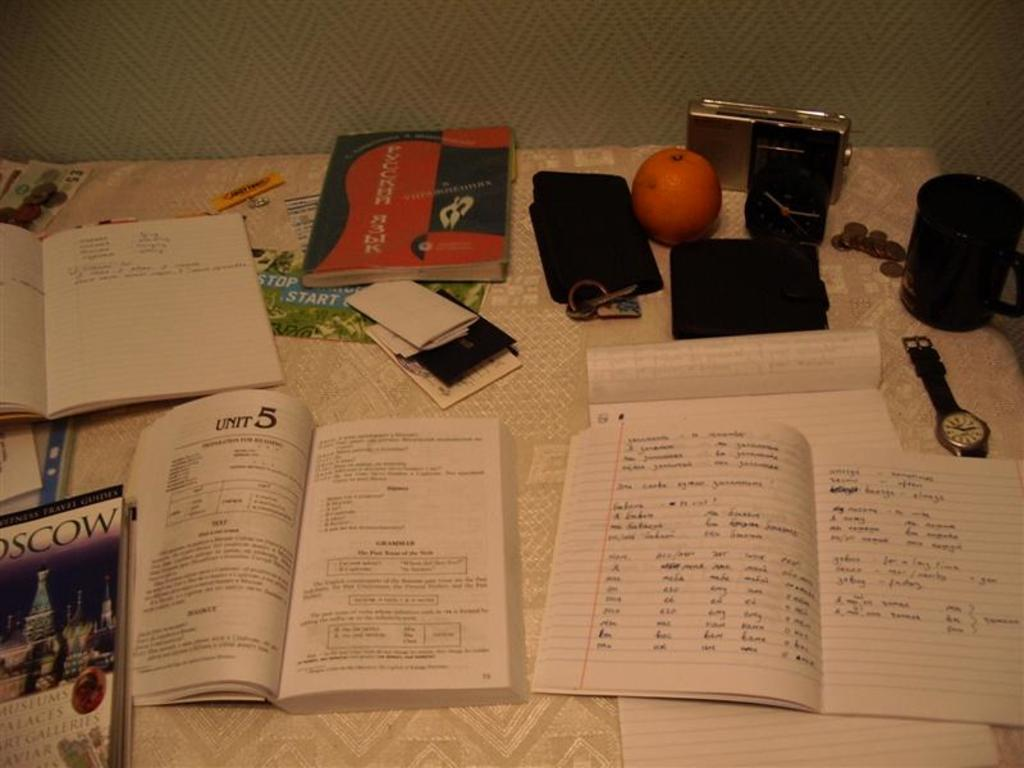<image>
Relay a brief, clear account of the picture shown. a book that is open to unit 5 next to a notebook 